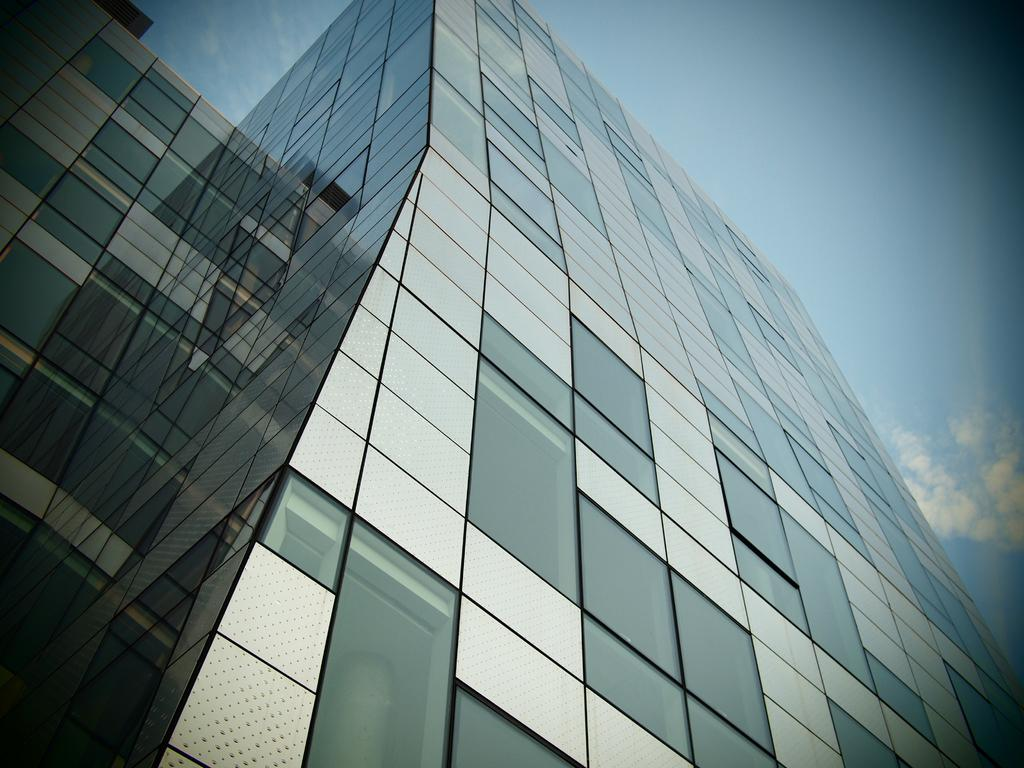What type of building is in the image? There is a tall glass building in the image. What can be seen at the top of the image? The sky is clear and visible at the top of the image. What type of pet can be seen playing with a basket in the image? There is no pet or basket present in the image; it only features a tall glass building and the clear sky. 